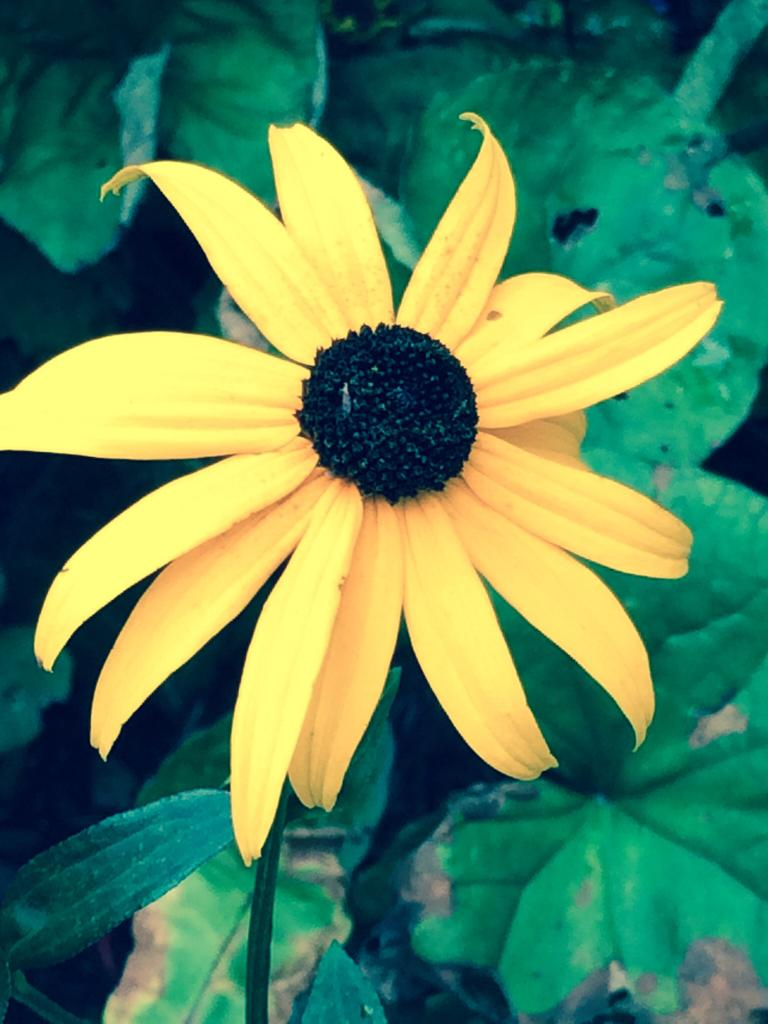What is the main subject of the picture? The main subject of the picture is a flower. What color are the petals of the flower? The flower has yellow petals. Are there any other parts of the flower visible in the image? Yes, there are green leaves associated with the flower. What type of soup is being served in the image? There is no soup present in the image; it features a flower with yellow petals and green leaves. 